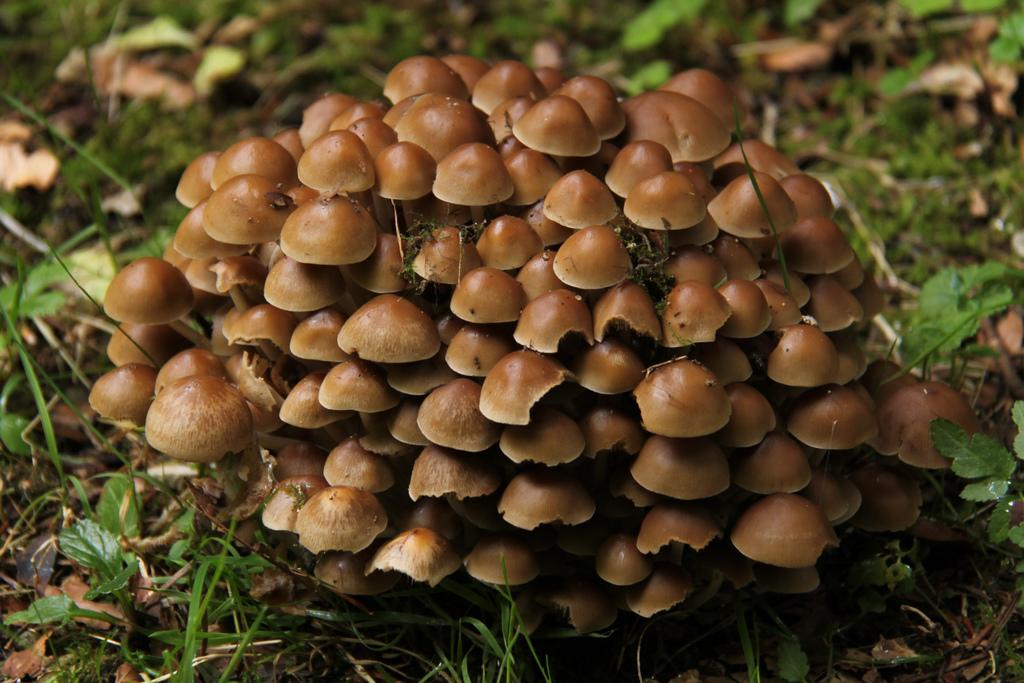What type of fungi can be seen in the image? There are mushrooms in the image. What is the color of the mushrooms? The mushrooms are brown in color. What type of vegetation is visible in the background of the image? There are plants in the background of the image. What is the color of the plants? The plants are green in color. What type of religion is being practiced in the image? There is no indication of any religious practice in the image; it features mushrooms and plants. 